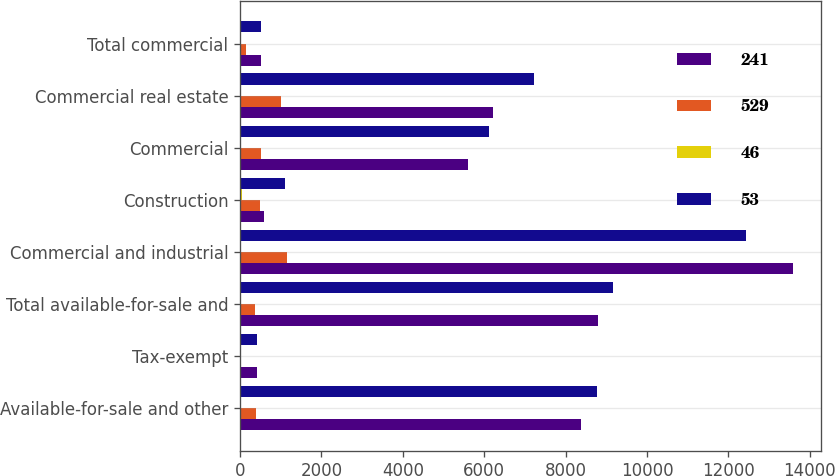Convert chart. <chart><loc_0><loc_0><loc_500><loc_500><stacked_bar_chart><ecel><fcel>Available-for-sale and other<fcel>Tax-exempt<fcel>Total available-for-sale and<fcel>Commercial and industrial<fcel>Construction<fcel>Commercial<fcel>Commercial real estate<fcel>Total commercial<nl><fcel>241<fcel>8371<fcel>428<fcel>8799<fcel>13597<fcel>592<fcel>5613<fcel>6205<fcel>510<nl><fcel>529<fcel>389<fcel>17<fcel>372<fcel>1166<fcel>504<fcel>516<fcel>1020<fcel>146<nl><fcel>46<fcel>4<fcel>4<fcel>4<fcel>9<fcel>46<fcel>8<fcel>14<fcel>1<nl><fcel>53<fcel>8760<fcel>411<fcel>9171<fcel>12431<fcel>1096<fcel>6129<fcel>7225<fcel>510<nl></chart> 